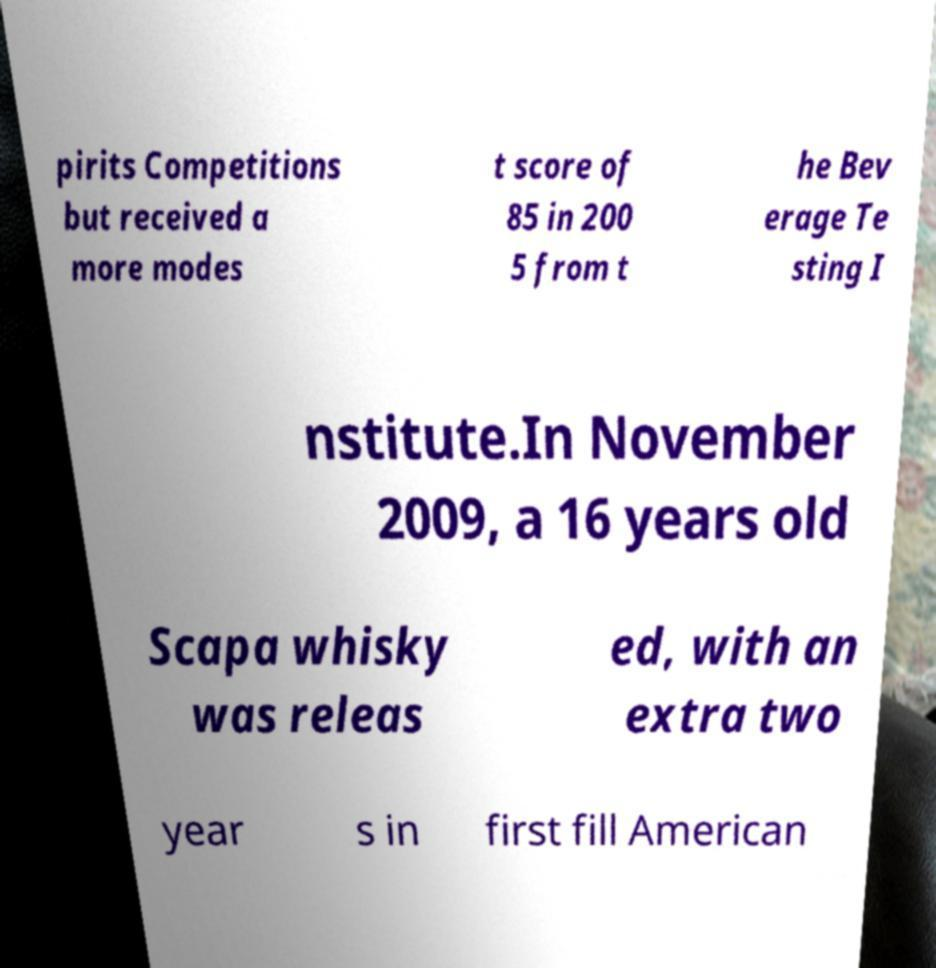Could you extract and type out the text from this image? pirits Competitions but received a more modes t score of 85 in 200 5 from t he Bev erage Te sting I nstitute.In November 2009, a 16 years old Scapa whisky was releas ed, with an extra two year s in first fill American 